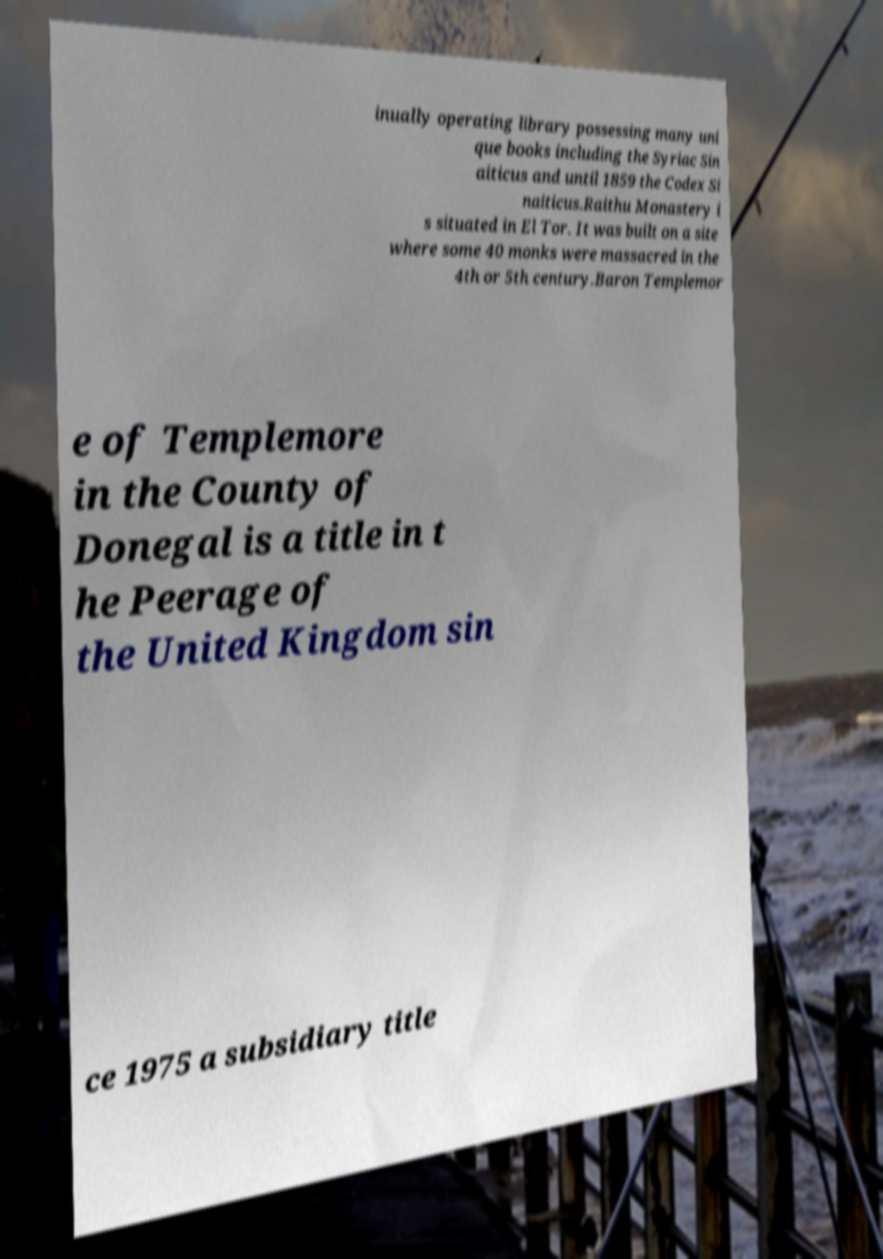What messages or text are displayed in this image? I need them in a readable, typed format. inually operating library possessing many uni que books including the Syriac Sin aiticus and until 1859 the Codex Si naiticus.Raithu Monastery i s situated in El Tor. It was built on a site where some 40 monks were massacred in the 4th or 5th century.Baron Templemor e of Templemore in the County of Donegal is a title in t he Peerage of the United Kingdom sin ce 1975 a subsidiary title 